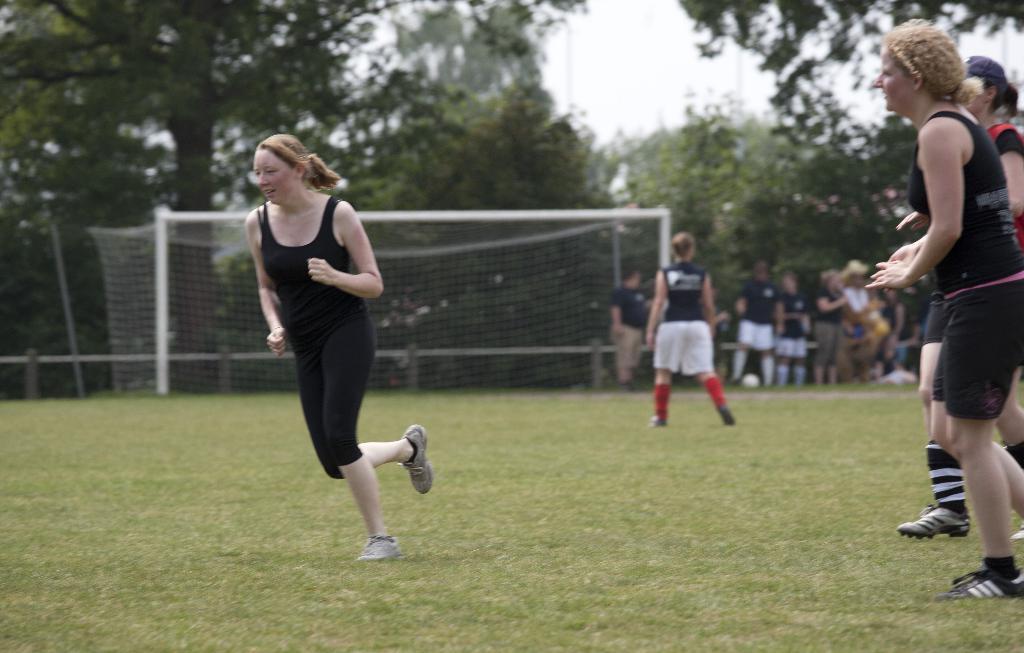Describe this image in one or two sentences. This woman running and these two people are walking on the grass. In the background we can see people,net,trees and sky. 